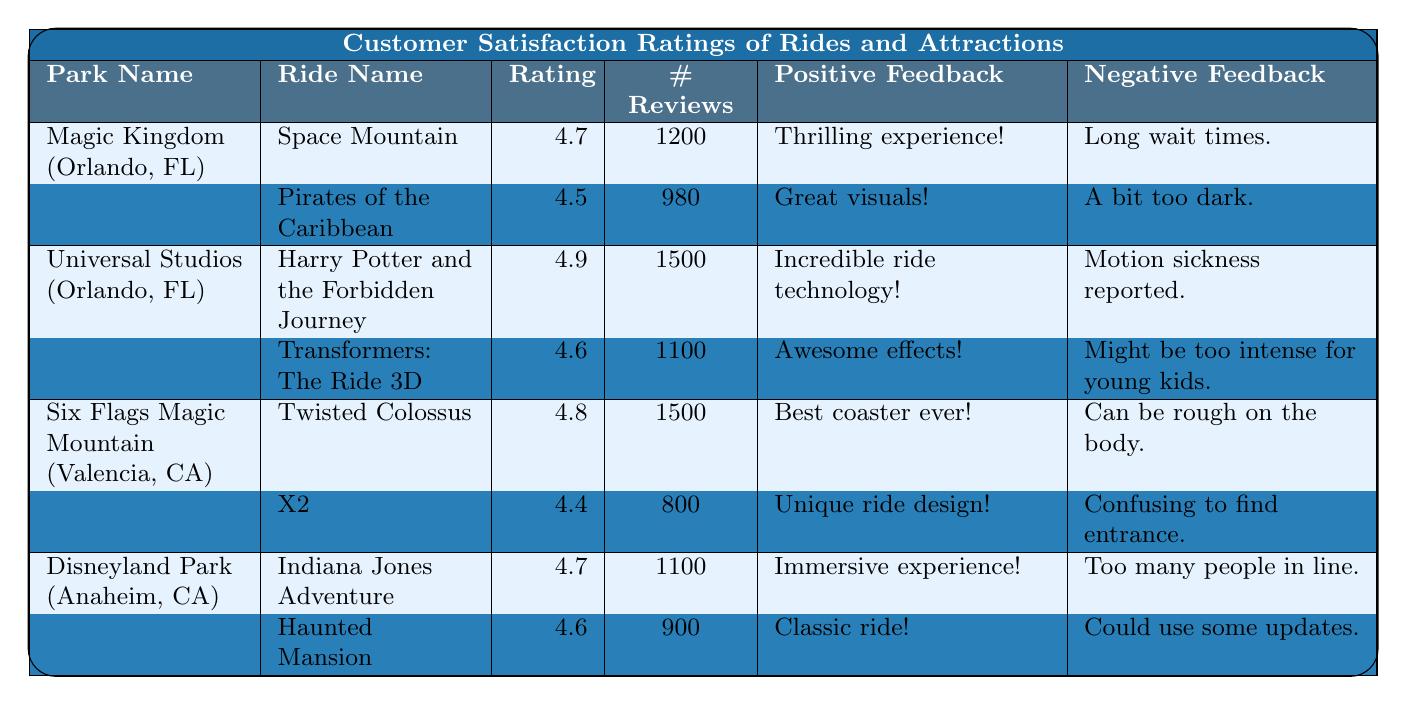What is the highest customer satisfaction rating for a ride in the table? The table shows ratings for each ride, with the highest rating being for "Harry Potter and the Forbidden Journey" at 4.9.
Answer: 4.9 Which park has the most rides listed in the table? The table indicates that each park has two rides listed, so there is no park with more rides than another.
Answer: None, all have the same number What is the average customer satisfaction rating for the rides at Six Flags Magic Mountain? The ratings for the rides at Six Flags Magic Mountain are 4.8 (Twisted Colossus) and 4.4 (X2). The average is calculated as (4.8 + 4.4) / 2 = 4.6.
Answer: 4.6 How many reviews did "Transformers: The Ride 3D" receive? The table states that "Transformers: The Ride 3D" received a total of 1100 reviews.
Answer: 1100 Is the feedback for "Space Mountain" more positive than negative? The feedback for "Space Mountain" includes two positive comments ("Thrilling experience!" and "Amazing theming!") versus two negative comments ("Long wait times." and "Hard to find signage."), indicating it has an equal count of positive and negative feedback.
Answer: No Which ride had the most reviews among the attractions listed? "Harry Potter and the Forbidden Journey" has the most reviews at 1500, as indicated in the table.
Answer: 1500 What is the combined number of reviews for all rides in Disneyland Park? The total reviews for rides in Disneyland Park are 1100 (Indiana Jones Adventure) + 900 (Haunted Mansion) = 2000.
Answer: 2000 Do more rides have a satisfaction rating above 4.5 than below in the table? Analyzing the ratings: "Space Mountain" (4.7), "Harry Potter and the Forbidden Journey" (4.9), "Twisted Colossus" (4.8), "Indiana Jones Adventure" (4.7), and "Haunted Mansion" (4.6) are all above 4.5, while "Pirates of the Caribbean" (4.5), "Transformers: The Ride 3D" (4.6), and "X2" (4.4) includes one at 4.4 below 4.5. Therefore, there are five rides above 4.5 and only one below.
Answer: Yes What percentage of reviews for "X2" are negative based on the feedback? "X2" has one positive feedback and two negative feedback, making a total of three feedbacks. The percentage of negative feedback is (2 negative / 3 total) * 100 = 66.67%.
Answer: 66.67% Which park features a ride that has "best coaster ever!" in its positive feedback? The ride "Twisted Colossus" at Six Flags Magic Mountain features "best coaster ever!" as part of its positive feedback.
Answer: Six Flags Magic Mountain 